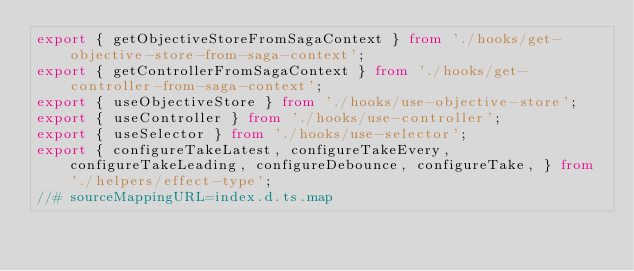Convert code to text. <code><loc_0><loc_0><loc_500><loc_500><_TypeScript_>export { getObjectiveStoreFromSagaContext } from './hooks/get-objective-store-from-saga-context';
export { getControllerFromSagaContext } from './hooks/get-controller-from-saga-context';
export { useObjectiveStore } from './hooks/use-objective-store';
export { useController } from './hooks/use-controller';
export { useSelector } from './hooks/use-selector';
export { configureTakeLatest, configureTakeEvery, configureTakeLeading, configureDebounce, configureTake, } from './helpers/effect-type';
//# sourceMappingURL=index.d.ts.map</code> 